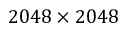<formula> <loc_0><loc_0><loc_500><loc_500>2 0 4 8 \times 2 0 4 8</formula> 